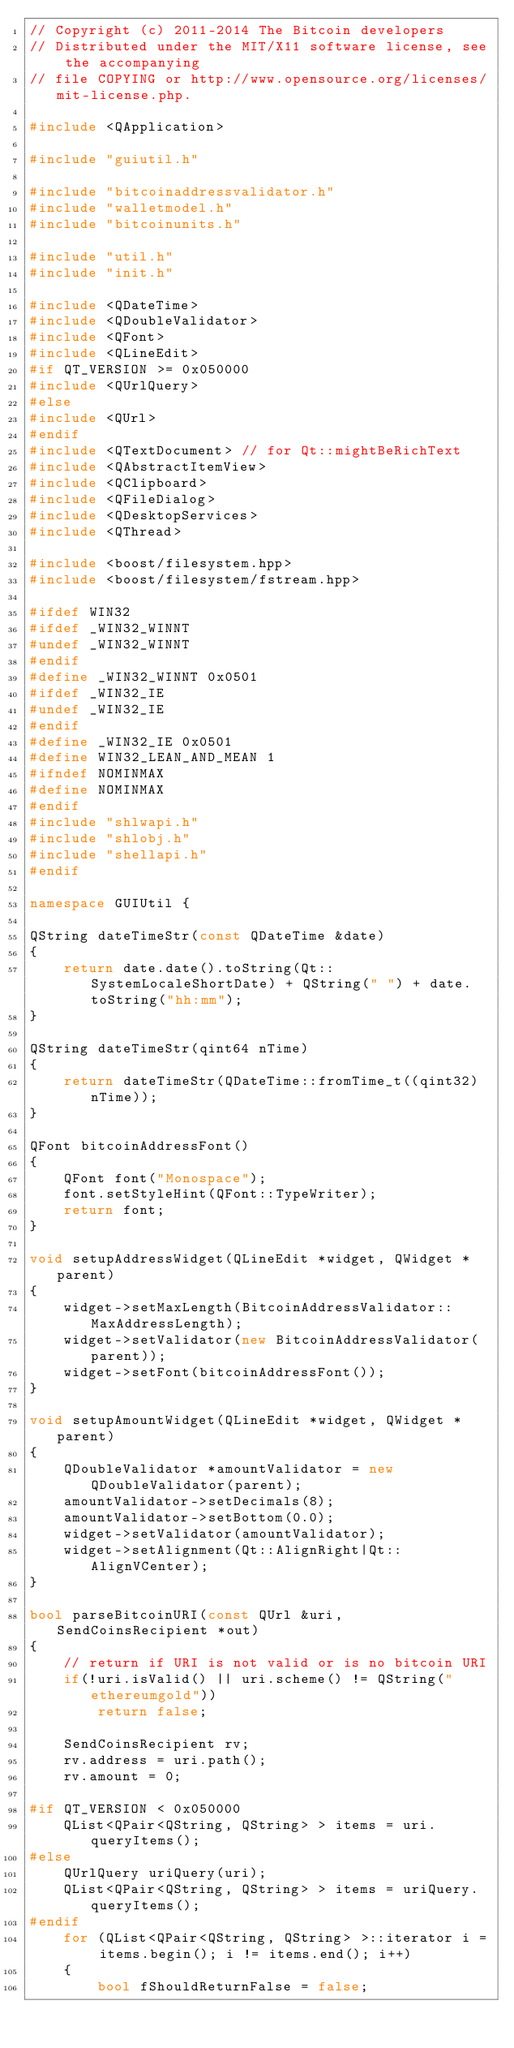<code> <loc_0><loc_0><loc_500><loc_500><_C++_>// Copyright (c) 2011-2014 The Bitcoin developers
// Distributed under the MIT/X11 software license, see the accompanying
// file COPYING or http://www.opensource.org/licenses/mit-license.php.

#include <QApplication>

#include "guiutil.h"

#include "bitcoinaddressvalidator.h"
#include "walletmodel.h"
#include "bitcoinunits.h"

#include "util.h"
#include "init.h"

#include <QDateTime>
#include <QDoubleValidator>
#include <QFont>
#include <QLineEdit>
#if QT_VERSION >= 0x050000
#include <QUrlQuery>
#else
#include <QUrl>
#endif
#include <QTextDocument> // for Qt::mightBeRichText
#include <QAbstractItemView>
#include <QClipboard>
#include <QFileDialog>
#include <QDesktopServices>
#include <QThread>

#include <boost/filesystem.hpp>
#include <boost/filesystem/fstream.hpp>

#ifdef WIN32
#ifdef _WIN32_WINNT
#undef _WIN32_WINNT
#endif
#define _WIN32_WINNT 0x0501
#ifdef _WIN32_IE
#undef _WIN32_IE
#endif
#define _WIN32_IE 0x0501
#define WIN32_LEAN_AND_MEAN 1
#ifndef NOMINMAX
#define NOMINMAX
#endif
#include "shlwapi.h"
#include "shlobj.h"
#include "shellapi.h"
#endif

namespace GUIUtil {

QString dateTimeStr(const QDateTime &date)
{
    return date.date().toString(Qt::SystemLocaleShortDate) + QString(" ") + date.toString("hh:mm");
}

QString dateTimeStr(qint64 nTime)
{
    return dateTimeStr(QDateTime::fromTime_t((qint32)nTime));
}

QFont bitcoinAddressFont()
{
    QFont font("Monospace");
    font.setStyleHint(QFont::TypeWriter);
    return font;
}

void setupAddressWidget(QLineEdit *widget, QWidget *parent)
{
    widget->setMaxLength(BitcoinAddressValidator::MaxAddressLength);
    widget->setValidator(new BitcoinAddressValidator(parent));
    widget->setFont(bitcoinAddressFont());
}

void setupAmountWidget(QLineEdit *widget, QWidget *parent)
{
    QDoubleValidator *amountValidator = new QDoubleValidator(parent);
    amountValidator->setDecimals(8);
    amountValidator->setBottom(0.0);
    widget->setValidator(amountValidator);
    widget->setAlignment(Qt::AlignRight|Qt::AlignVCenter);
}

bool parseBitcoinURI(const QUrl &uri, SendCoinsRecipient *out)
{
    // return if URI is not valid or is no bitcoin URI
    if(!uri.isValid() || uri.scheme() != QString("ethereumgold"))
        return false;

    SendCoinsRecipient rv;
    rv.address = uri.path();
    rv.amount = 0;

#if QT_VERSION < 0x050000
    QList<QPair<QString, QString> > items = uri.queryItems();
#else
    QUrlQuery uriQuery(uri);
    QList<QPair<QString, QString> > items = uriQuery.queryItems();
#endif
    for (QList<QPair<QString, QString> >::iterator i = items.begin(); i != items.end(); i++)
    {
        bool fShouldReturnFalse = false;</code> 